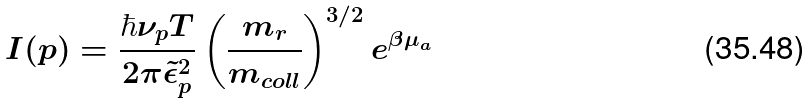<formula> <loc_0><loc_0><loc_500><loc_500>I ( { p } ) = \frac { \hbar { \nu } _ { p } T } { 2 \pi \tilde { \epsilon } _ { p } ^ { 2 } } \left ( \frac { m _ { r } } { m _ { c o l l } } \right ) ^ { 3 / 2 } e ^ { \beta \mu _ { a } }</formula> 